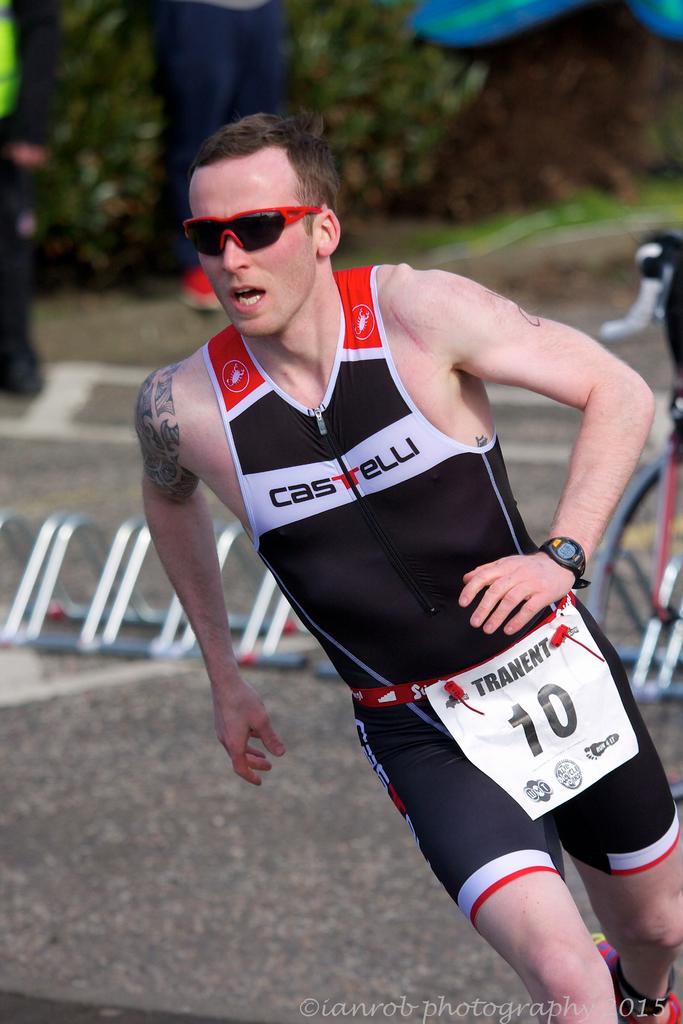What number is he?
Offer a very short reply. 10. What is written across his chest?
Your answer should be very brief. Castelli. 